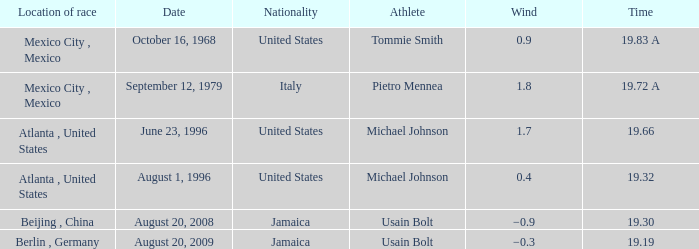What's the wind when the time was 19.32? 0.4. 